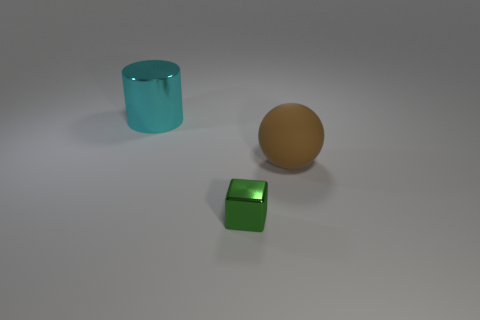Add 2 small metal things. How many objects exist? 5 Subtract all spheres. How many objects are left? 2 Subtract 0 gray cylinders. How many objects are left? 3 Subtract all tiny yellow shiny objects. Subtract all large things. How many objects are left? 1 Add 3 brown rubber balls. How many brown rubber balls are left? 4 Add 1 cyan shiny cylinders. How many cyan shiny cylinders exist? 2 